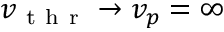Convert formula to latex. <formula><loc_0><loc_0><loc_500><loc_500>v _ { t h r } \to v _ { p } = \infty</formula> 